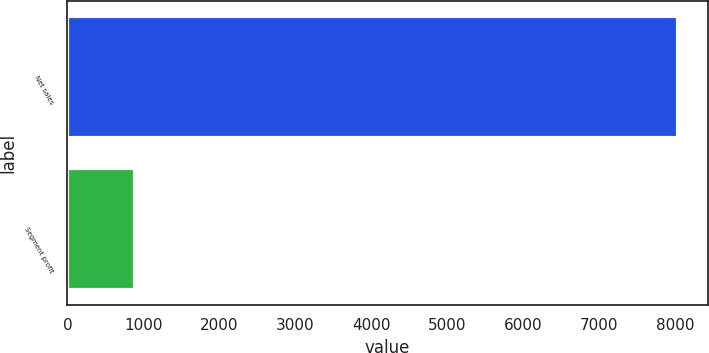<chart> <loc_0><loc_0><loc_500><loc_500><bar_chart><fcel>Net sales<fcel>Segment profit<nl><fcel>8031<fcel>894<nl></chart> 